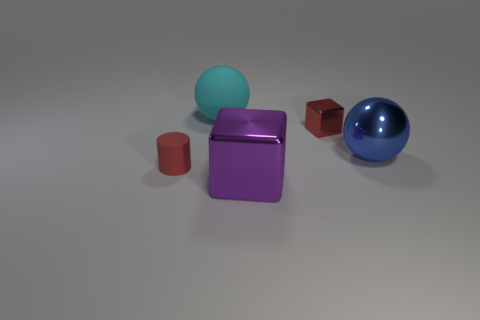Is the number of tiny blocks less than the number of tiny blue metallic spheres? no 